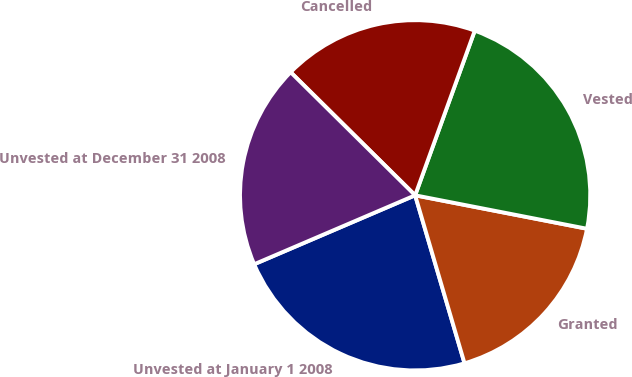<chart> <loc_0><loc_0><loc_500><loc_500><pie_chart><fcel>Unvested at January 1 2008<fcel>Granted<fcel>Vested<fcel>Cancelled<fcel>Unvested at December 31 2008<nl><fcel>23.11%<fcel>17.39%<fcel>22.53%<fcel>18.12%<fcel>18.85%<nl></chart> 